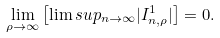Convert formula to latex. <formula><loc_0><loc_0><loc_500><loc_500>\lim _ { \rho \to \infty } \left [ \lim s u p _ { n \to \infty } | I _ { n , \rho } ^ { 1 } | \right ] = 0 .</formula> 